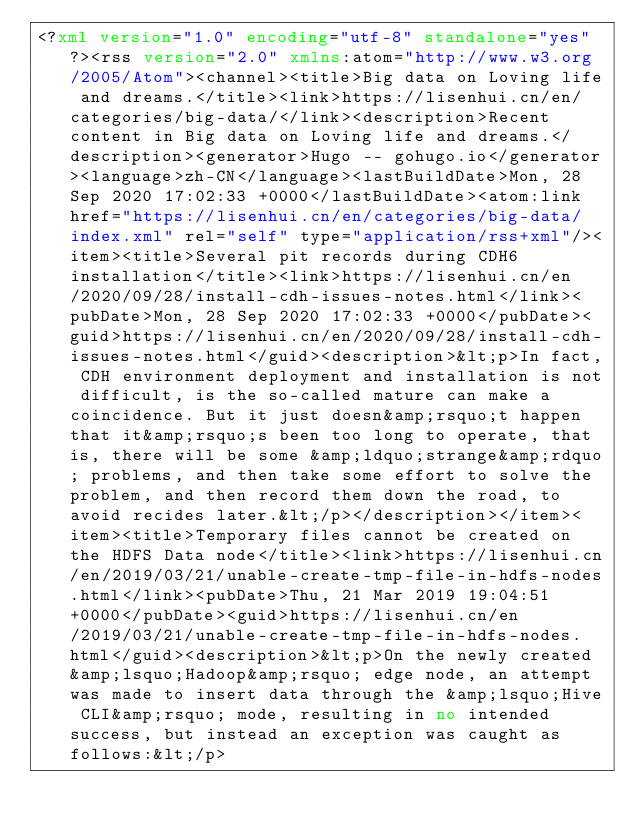<code> <loc_0><loc_0><loc_500><loc_500><_XML_><?xml version="1.0" encoding="utf-8" standalone="yes"?><rss version="2.0" xmlns:atom="http://www.w3.org/2005/Atom"><channel><title>Big data on Loving life and dreams.</title><link>https://lisenhui.cn/en/categories/big-data/</link><description>Recent content in Big data on Loving life and dreams.</description><generator>Hugo -- gohugo.io</generator><language>zh-CN</language><lastBuildDate>Mon, 28 Sep 2020 17:02:33 +0000</lastBuildDate><atom:link href="https://lisenhui.cn/en/categories/big-data/index.xml" rel="self" type="application/rss+xml"/><item><title>Several pit records during CDH6 installation</title><link>https://lisenhui.cn/en/2020/09/28/install-cdh-issues-notes.html</link><pubDate>Mon, 28 Sep 2020 17:02:33 +0000</pubDate><guid>https://lisenhui.cn/en/2020/09/28/install-cdh-issues-notes.html</guid><description>&lt;p>In fact, CDH environment deployment and installation is not difficult, is the so-called mature can make a coincidence. But it just doesn&amp;rsquo;t happen that it&amp;rsquo;s been too long to operate, that is, there will be some &amp;ldquo;strange&amp;rdquo; problems, and then take some effort to solve the problem, and then record them down the road, to avoid recides later.&lt;/p></description></item><item><title>Temporary files cannot be created on the HDFS Data node</title><link>https://lisenhui.cn/en/2019/03/21/unable-create-tmp-file-in-hdfs-nodes.html</link><pubDate>Thu, 21 Mar 2019 19:04:51 +0000</pubDate><guid>https://lisenhui.cn/en/2019/03/21/unable-create-tmp-file-in-hdfs-nodes.html</guid><description>&lt;p>On the newly created &amp;lsquo;Hadoop&amp;rsquo; edge node, an attempt was made to insert data through the &amp;lsquo;Hive CLI&amp;rsquo; mode, resulting in no intended success, but instead an exception was caught as follows:&lt;/p></code> 